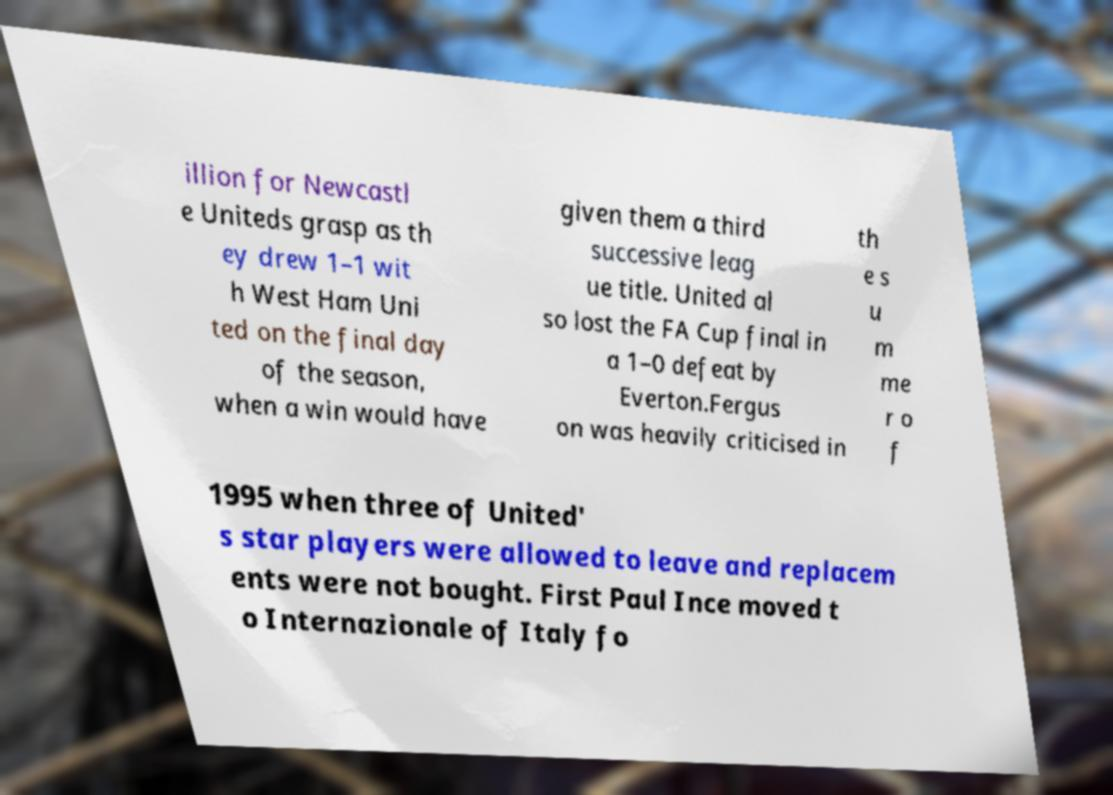Please identify and transcribe the text found in this image. illion for Newcastl e Uniteds grasp as th ey drew 1–1 wit h West Ham Uni ted on the final day of the season, when a win would have given them a third successive leag ue title. United al so lost the FA Cup final in a 1–0 defeat by Everton.Fergus on was heavily criticised in th e s u m me r o f 1995 when three of United' s star players were allowed to leave and replacem ents were not bought. First Paul Ince moved t o Internazionale of Italy fo 